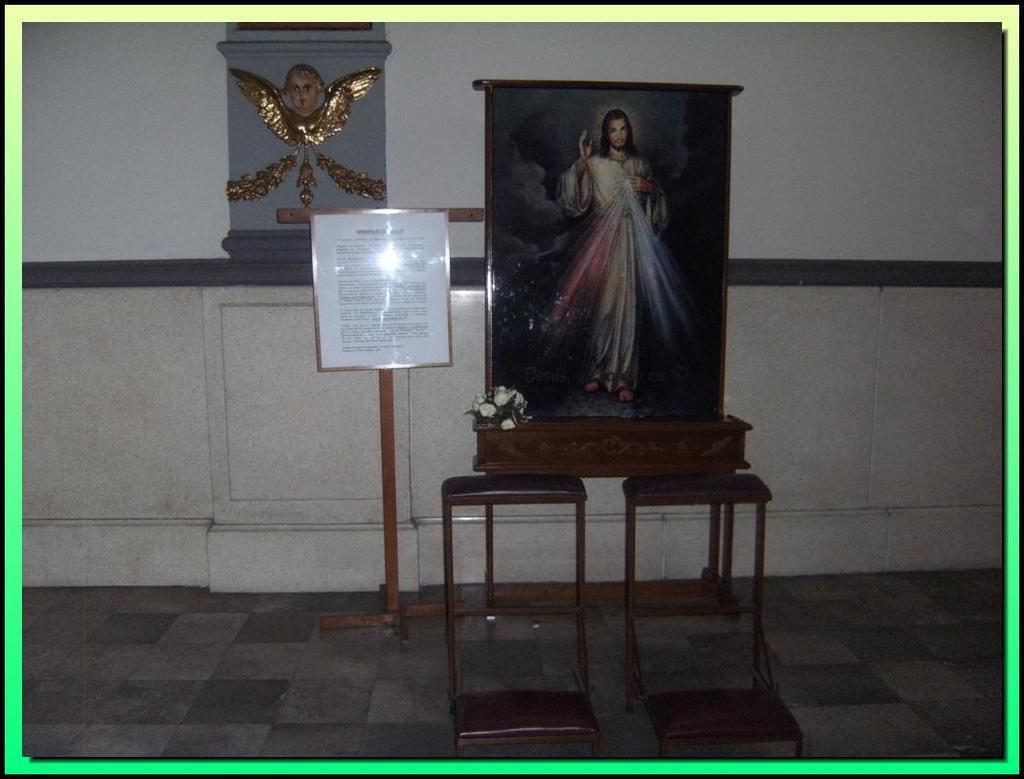Describe this image in one or two sentences. This picture shows a photo frame and a flower vase and we see couple of tables and we see a paper with text to the stand and we see carving on the wall. 